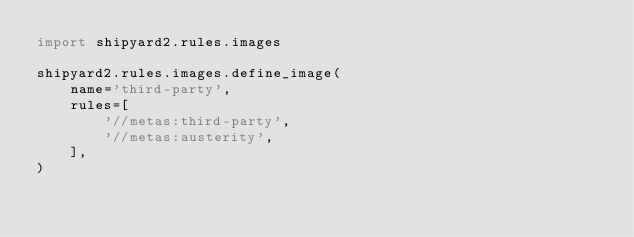<code> <loc_0><loc_0><loc_500><loc_500><_Python_>import shipyard2.rules.images

shipyard2.rules.images.define_image(
    name='third-party',
    rules=[
        '//metas:third-party',
        '//metas:austerity',
    ],
)
</code> 